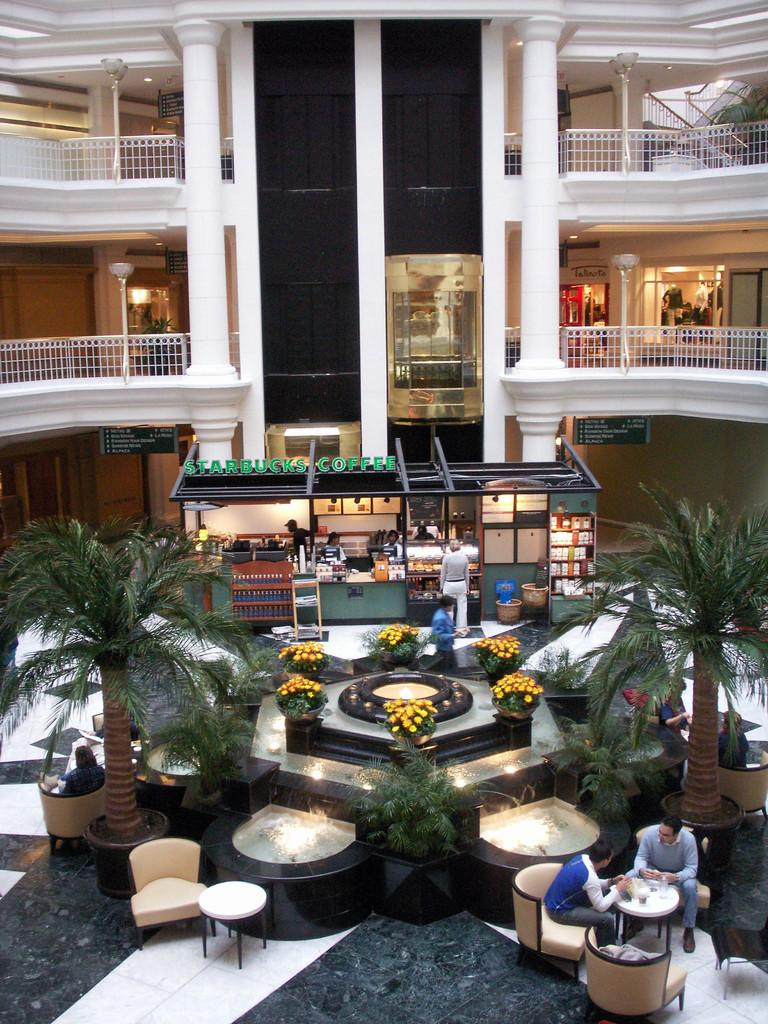<image>
Relay a brief, clear account of the picture shown. Starbucks Coffee building in the middle of a mall with a nice flower display next to it. 